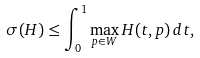Convert formula to latex. <formula><loc_0><loc_0><loc_500><loc_500>\label l { e q \colon \max - t o - s i g m a } \sigma ( H ) \leq \int _ { 0 } ^ { 1 } \max _ { p \in W } H ( t , p ) \, d t ,</formula> 